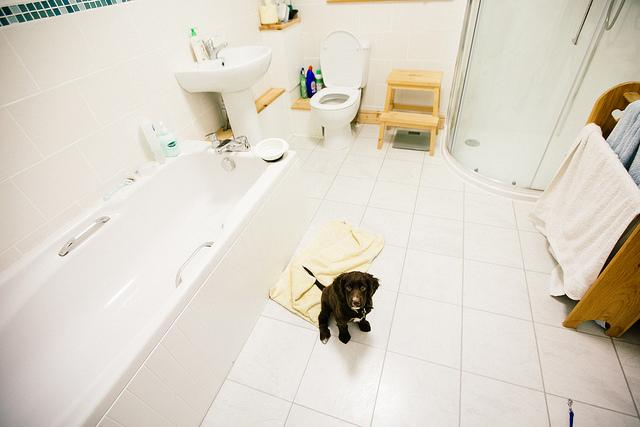Why might the dog be near the tub? bath time 